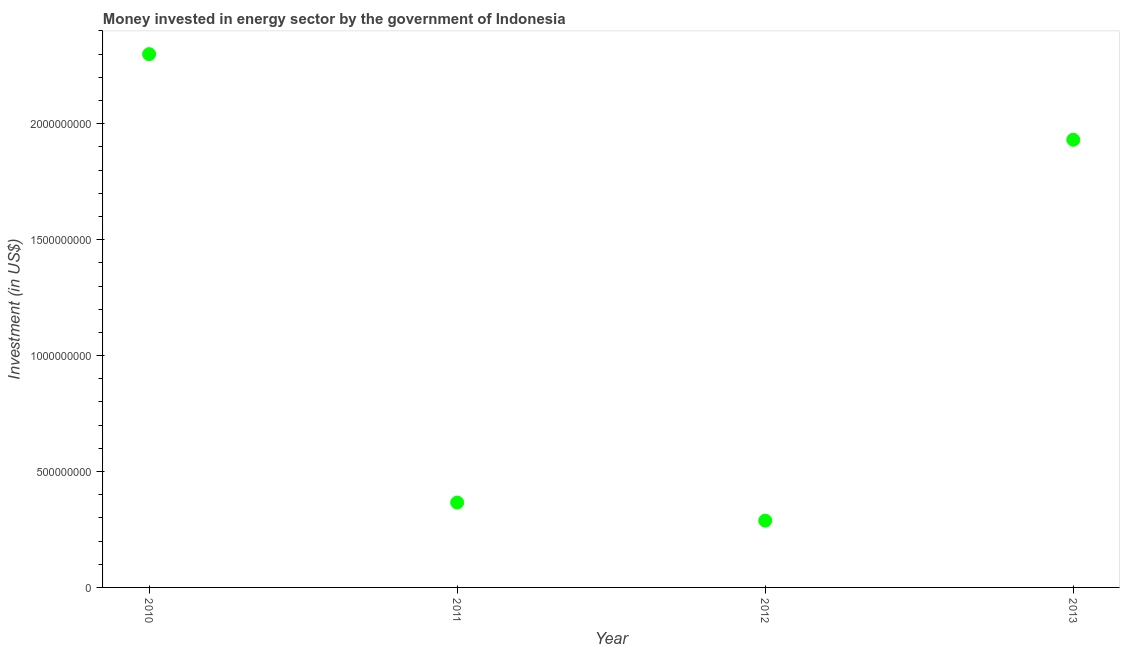What is the investment in energy in 2012?
Your answer should be compact. 2.88e+08. Across all years, what is the maximum investment in energy?
Your answer should be very brief. 2.30e+09. Across all years, what is the minimum investment in energy?
Provide a short and direct response. 2.88e+08. In which year was the investment in energy minimum?
Make the answer very short. 2012. What is the sum of the investment in energy?
Your answer should be compact. 4.88e+09. What is the difference between the investment in energy in 2010 and 2011?
Ensure brevity in your answer.  1.93e+09. What is the average investment in energy per year?
Offer a very short reply. 1.22e+09. What is the median investment in energy?
Your answer should be very brief. 1.15e+09. In how many years, is the investment in energy greater than 1000000000 US$?
Ensure brevity in your answer.  2. What is the ratio of the investment in energy in 2011 to that in 2012?
Your answer should be compact. 1.27. Is the difference between the investment in energy in 2010 and 2012 greater than the difference between any two years?
Keep it short and to the point. Yes. What is the difference between the highest and the second highest investment in energy?
Provide a short and direct response. 3.69e+08. Is the sum of the investment in energy in 2012 and 2013 greater than the maximum investment in energy across all years?
Give a very brief answer. No. What is the difference between the highest and the lowest investment in energy?
Ensure brevity in your answer.  2.01e+09. Does the investment in energy monotonically increase over the years?
Offer a very short reply. No. How many dotlines are there?
Your answer should be very brief. 1. Are the values on the major ticks of Y-axis written in scientific E-notation?
Keep it short and to the point. No. Does the graph contain any zero values?
Your answer should be compact. No. What is the title of the graph?
Offer a very short reply. Money invested in energy sector by the government of Indonesia. What is the label or title of the X-axis?
Keep it short and to the point. Year. What is the label or title of the Y-axis?
Your response must be concise. Investment (in US$). What is the Investment (in US$) in 2010?
Offer a very short reply. 2.30e+09. What is the Investment (in US$) in 2011?
Your answer should be compact. 3.66e+08. What is the Investment (in US$) in 2012?
Provide a short and direct response. 2.88e+08. What is the Investment (in US$) in 2013?
Offer a very short reply. 1.93e+09. What is the difference between the Investment (in US$) in 2010 and 2011?
Ensure brevity in your answer.  1.93e+09. What is the difference between the Investment (in US$) in 2010 and 2012?
Your answer should be very brief. 2.01e+09. What is the difference between the Investment (in US$) in 2010 and 2013?
Ensure brevity in your answer.  3.69e+08. What is the difference between the Investment (in US$) in 2011 and 2012?
Make the answer very short. 7.80e+07. What is the difference between the Investment (in US$) in 2011 and 2013?
Provide a succinct answer. -1.56e+09. What is the difference between the Investment (in US$) in 2012 and 2013?
Keep it short and to the point. -1.64e+09. What is the ratio of the Investment (in US$) in 2010 to that in 2011?
Offer a very short reply. 6.28. What is the ratio of the Investment (in US$) in 2010 to that in 2012?
Your response must be concise. 7.99. What is the ratio of the Investment (in US$) in 2010 to that in 2013?
Provide a short and direct response. 1.19. What is the ratio of the Investment (in US$) in 2011 to that in 2012?
Offer a terse response. 1.27. What is the ratio of the Investment (in US$) in 2011 to that in 2013?
Offer a terse response. 0.19. What is the ratio of the Investment (in US$) in 2012 to that in 2013?
Ensure brevity in your answer.  0.15. 